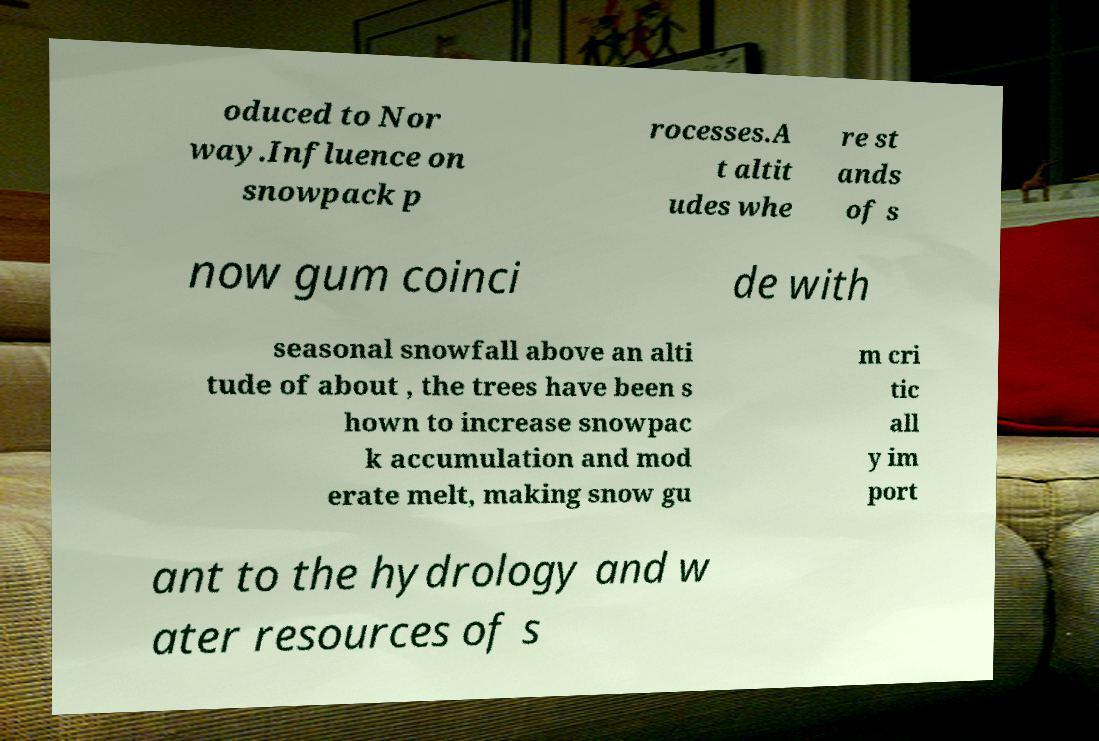Could you extract and type out the text from this image? oduced to Nor way.Influence on snowpack p rocesses.A t altit udes whe re st ands of s now gum coinci de with seasonal snowfall above an alti tude of about , the trees have been s hown to increase snowpac k accumulation and mod erate melt, making snow gu m cri tic all y im port ant to the hydrology and w ater resources of s 